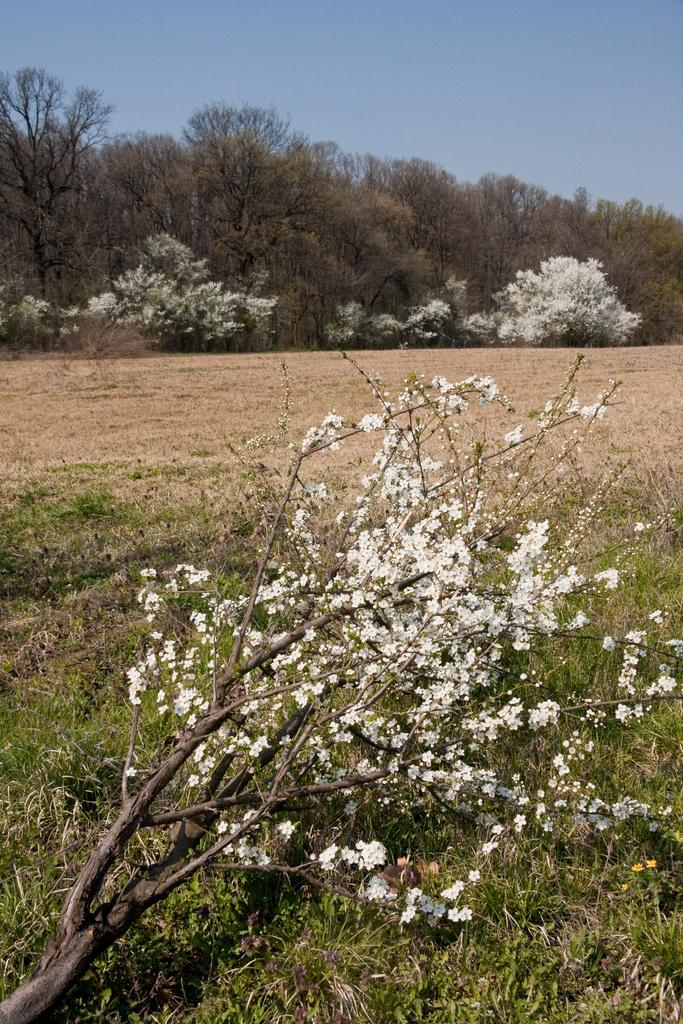What type of plants are present in the image? There are flowers with branches in the image. What type of vegetation is visible on the ground? There is grass visible in the image. What type of terrain is shown in the image? There is land in the image. What type of trees are present in the image? There are trees in the image. What is visible at the top of the image? The sky is visible at the top of the image. What type of rice is being prepared by the daughter in the image? There is no daughter or rice present in the image. How does the wash cycle affect the flowers in the image? There is no washing machine or washing cycle present in the image, so it does not affect the flowers. 